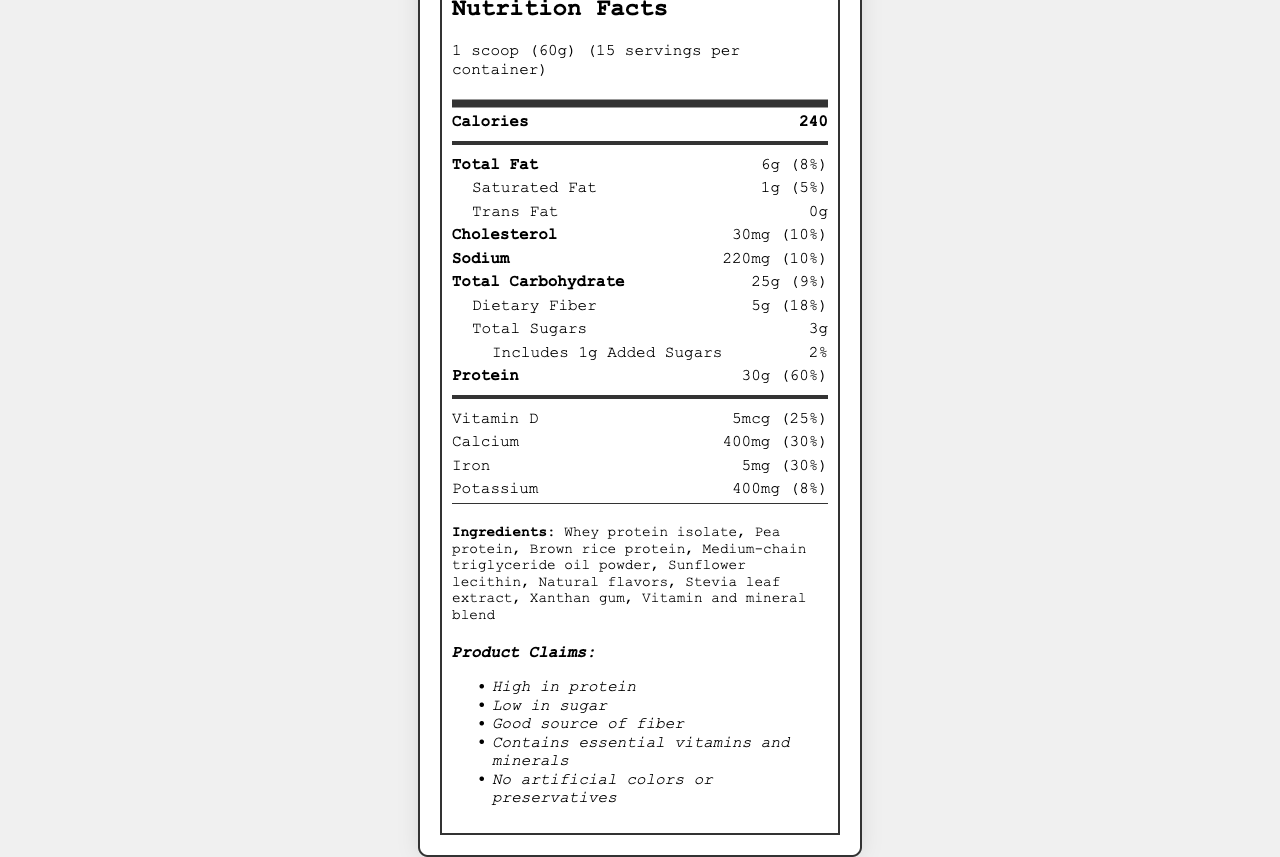what is the serving size of TechFuel Pro Shake? The serving size is specified under the product name as "1 scoop (60g)".
Answer: 1 scoop (60g) how many calories are there per serving? The calorie count per serving is clearly listed as "240" under the "Calories" section.
Answer: 240 what is the amount of total fat per serving? The total fat amount per serving is listed under "Total Fat" as "6g".
Answer: 6g what is the daily value percentage of protein per serving? The daily value percentage for protein per serving is provided as "60%" next to the amount of protein.
Answer: 60% what is the total carbohydrate amount per serving? The total carbohydrate amount is indicated under "Total Carbohydrate" as "25g".
Answer: 25g How much dietary fiber is in the shake? The dietary fiber content is listed as "5g" under the "Total Carbohydrate" section and further specified as "Dietary Fiber".
Answer: 5g How much added sugar is in the shake? The amount of added sugars is clearly listed as "1g" next to the “Includes” marker under "Total Sugars".
Answer: 1g What ingredient is listed first in the ingredients list? A. Natural flavors B. Whey protein isolate C. Stevia leaf extract D. Vitamin and mineral blend According to the ingredient list provided, "Whey protein isolate" is the first ingredient.
Answer: B. Whey protein isolate Which of these vitamins does TechFuel Pro Shake contain? I. Vitamin A II. Vitamin C III. Vitamin E IV. Vitamin K  A. I and III only B. II and IV only C. I, II, III, and IV D. I, II, and III The shake contains Vitamin A (450mcg), Vitamin C (45mg), Vitamin E (7.5mg), and Vitamin K (60mcg) as indicated in the vitamins and minerals section.
Answer: C. I, II, III, and IV Does TechFuel Pro Shake contain any trans fat? The label specifies "Trans Fat: 0g".
Answer: No Summarize the main nutritional highlights of TechFuel Pro Shake. The summary captures key information from various sections, including its protein content, vitamins and minerals, low sugar factor, and other product claims.
Answer: TechFuel Pro Shake is a high-protein meal replacement designed for IT professionals. It offers 30g of protein per serving, with essential vitamins and minerals, and is low in sugar (1g added sugar) and high in dietary fiber (5g). It also features a blend of different protein sources and has no artificial colors or preservatives. Does this shake contain artificial colors or preservatives? One of the product claims is "No artificial colors or preservatives."
Answer: No What type of facility is TechFuel Pro Shake produced in? The allergen information section details that it contains milk and is produced in a facility that processes soy, egg, tree nuts, and wheat.
Answer: Produced in a facility that also processes soy, egg, tree nuts, and wheat What is the main idea of this document? The main idea encompasses the product’s purpose and key nutritional insights provided by the document.
Answer: The document provides detailed nutritional information, ingredients, and product claims for the TechFuel Pro Shake, highlighting its suitability as a high-protein meal replacement for busy IT professionals. What is the manufacturing date of TechFuel Pro Shake? The document does not provide any information regarding the manufacturing date of the product.
Answer: Cannot be determined 